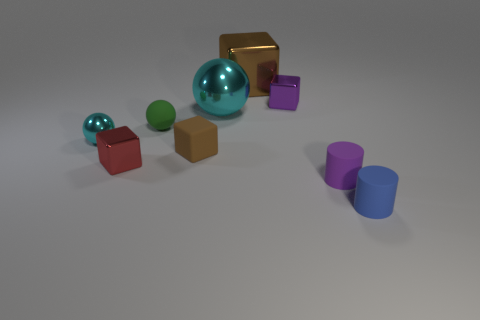Add 1 purple matte balls. How many objects exist? 10 Subtract all blocks. How many objects are left? 5 Subtract 0 gray blocks. How many objects are left? 9 Subtract all small matte spheres. Subtract all big brown blocks. How many objects are left? 7 Add 4 big blocks. How many big blocks are left? 5 Add 5 small purple matte things. How many small purple matte things exist? 6 